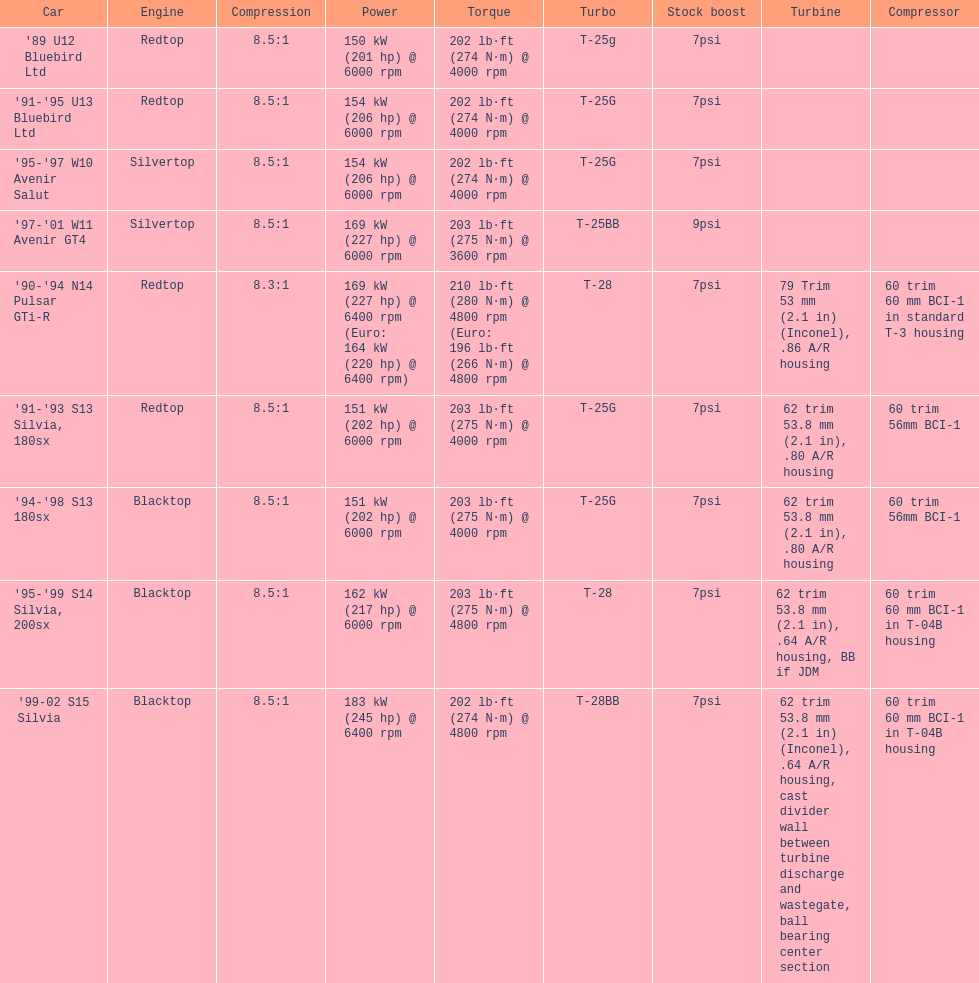Which automobile's strength is assessed above 6000 rpm? '90-'94 N14 Pulsar GTi-R, '99-02 S15 Silvia. 